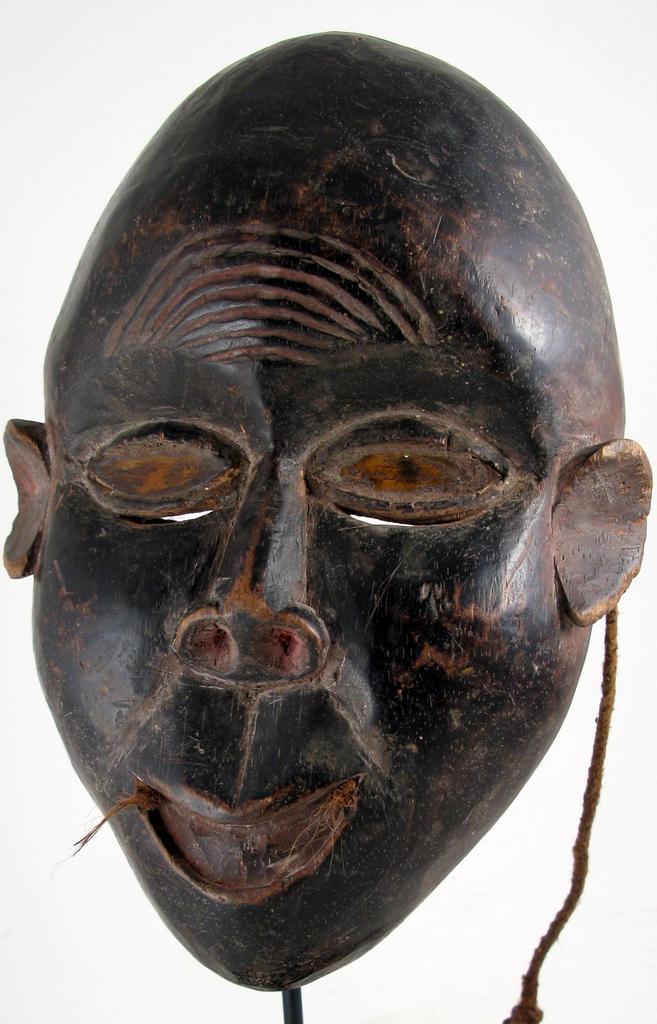Can you describe this image briefly? In this picture we can see a mask here, we can see white color background. 